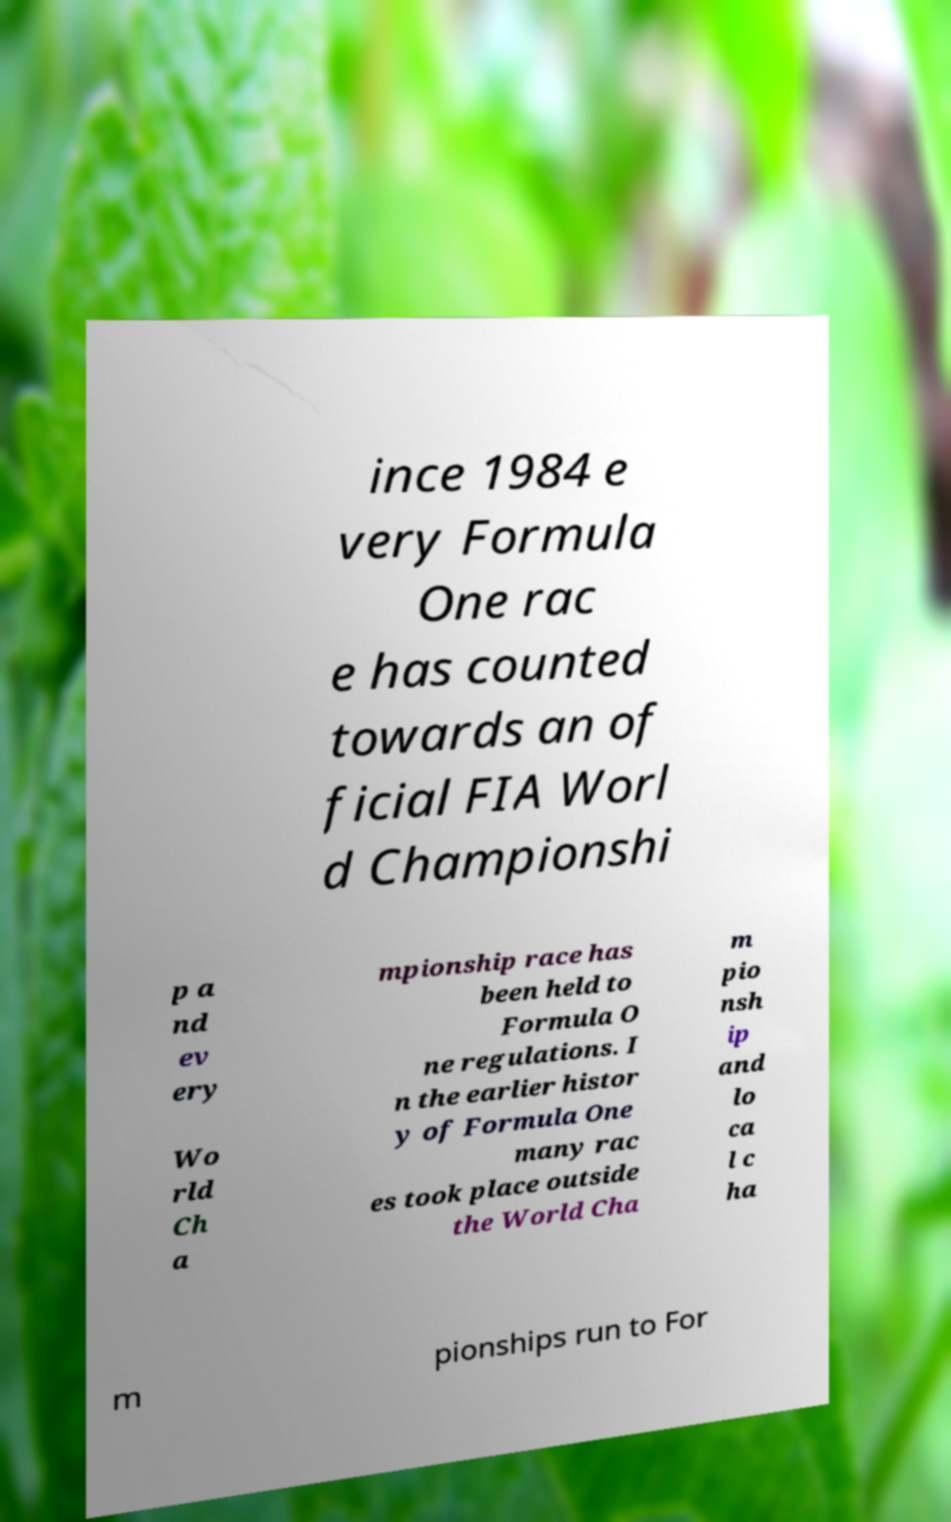Please identify and transcribe the text found in this image. ince 1984 e very Formula One rac e has counted towards an of ficial FIA Worl d Championshi p a nd ev ery Wo rld Ch a mpionship race has been held to Formula O ne regulations. I n the earlier histor y of Formula One many rac es took place outside the World Cha m pio nsh ip and lo ca l c ha m pionships run to For 